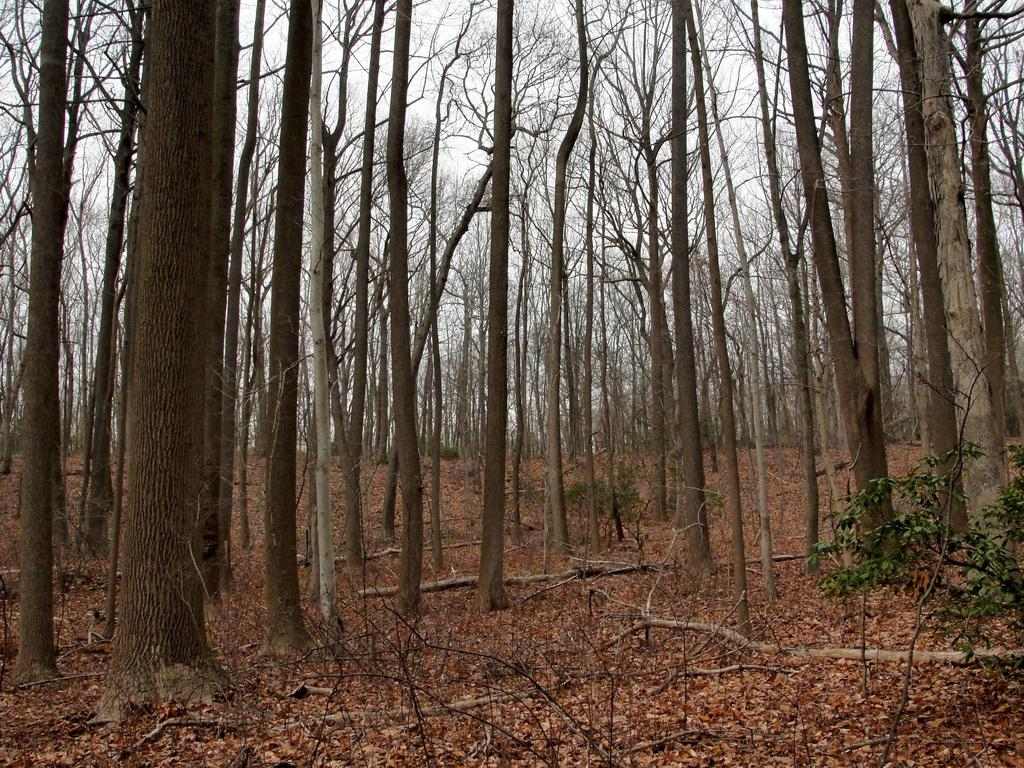What is present at the bottom of the image? There are dried leaves at the bottom of the image. What can be seen in the middle of the image? There are big trees in the middle of the image. What is visible at the top of the image? The sky is visible at the top of the image. What type of canvas is being used by the farmer in the image? There is no farmer or canvas present in the image. What knowledge can be gained from the image about the trees? The image provides information about the size of the trees, but it does not convey any specific knowledge about them. 